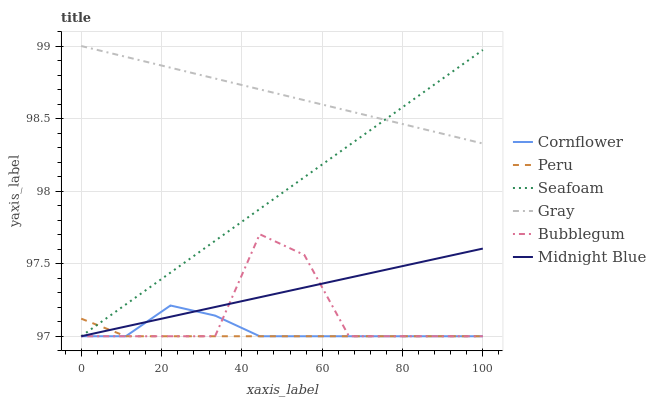Does Peru have the minimum area under the curve?
Answer yes or no. Yes. Does Gray have the maximum area under the curve?
Answer yes or no. Yes. Does Midnight Blue have the minimum area under the curve?
Answer yes or no. No. Does Midnight Blue have the maximum area under the curve?
Answer yes or no. No. Is Seafoam the smoothest?
Answer yes or no. Yes. Is Bubblegum the roughest?
Answer yes or no. Yes. Is Midnight Blue the smoothest?
Answer yes or no. No. Is Midnight Blue the roughest?
Answer yes or no. No. Does Cornflower have the lowest value?
Answer yes or no. Yes. Does Gray have the lowest value?
Answer yes or no. No. Does Gray have the highest value?
Answer yes or no. Yes. Does Midnight Blue have the highest value?
Answer yes or no. No. Is Midnight Blue less than Gray?
Answer yes or no. Yes. Is Gray greater than Midnight Blue?
Answer yes or no. Yes. Does Cornflower intersect Midnight Blue?
Answer yes or no. Yes. Is Cornflower less than Midnight Blue?
Answer yes or no. No. Is Cornflower greater than Midnight Blue?
Answer yes or no. No. Does Midnight Blue intersect Gray?
Answer yes or no. No. 